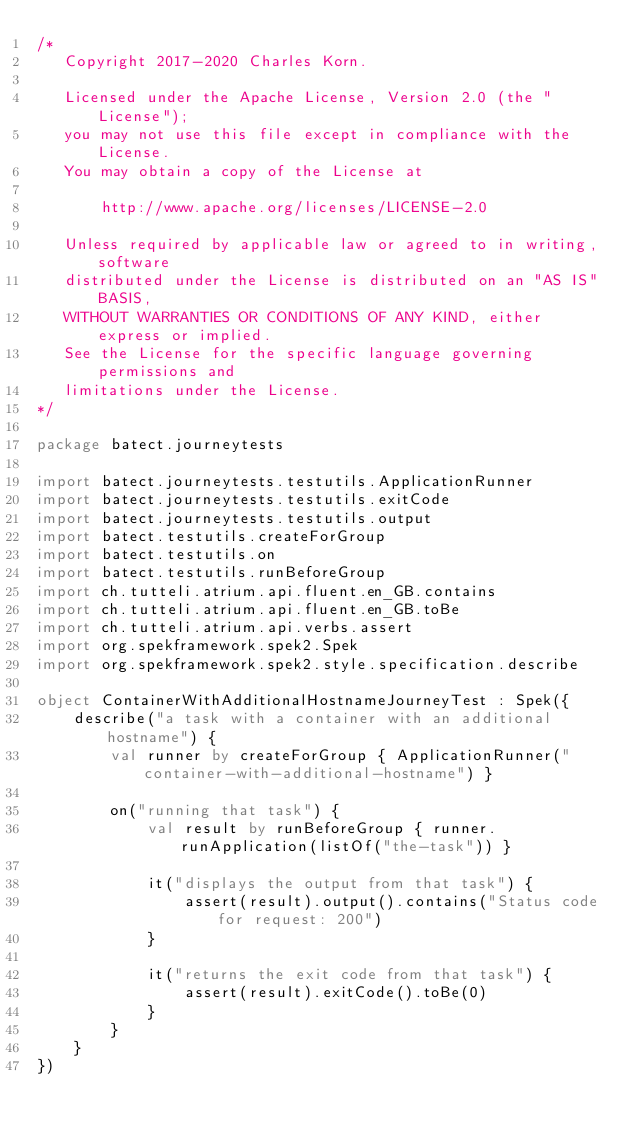<code> <loc_0><loc_0><loc_500><loc_500><_Kotlin_>/*
   Copyright 2017-2020 Charles Korn.

   Licensed under the Apache License, Version 2.0 (the "License");
   you may not use this file except in compliance with the License.
   You may obtain a copy of the License at

       http://www.apache.org/licenses/LICENSE-2.0

   Unless required by applicable law or agreed to in writing, software
   distributed under the License is distributed on an "AS IS" BASIS,
   WITHOUT WARRANTIES OR CONDITIONS OF ANY KIND, either express or implied.
   See the License for the specific language governing permissions and
   limitations under the License.
*/

package batect.journeytests

import batect.journeytests.testutils.ApplicationRunner
import batect.journeytests.testutils.exitCode
import batect.journeytests.testutils.output
import batect.testutils.createForGroup
import batect.testutils.on
import batect.testutils.runBeforeGroup
import ch.tutteli.atrium.api.fluent.en_GB.contains
import ch.tutteli.atrium.api.fluent.en_GB.toBe
import ch.tutteli.atrium.api.verbs.assert
import org.spekframework.spek2.Spek
import org.spekframework.spek2.style.specification.describe

object ContainerWithAdditionalHostnameJourneyTest : Spek({
    describe("a task with a container with an additional hostname") {
        val runner by createForGroup { ApplicationRunner("container-with-additional-hostname") }

        on("running that task") {
            val result by runBeforeGroup { runner.runApplication(listOf("the-task")) }

            it("displays the output from that task") {
                assert(result).output().contains("Status code for request: 200")
            }

            it("returns the exit code from that task") {
                assert(result).exitCode().toBe(0)
            }
        }
    }
})
</code> 